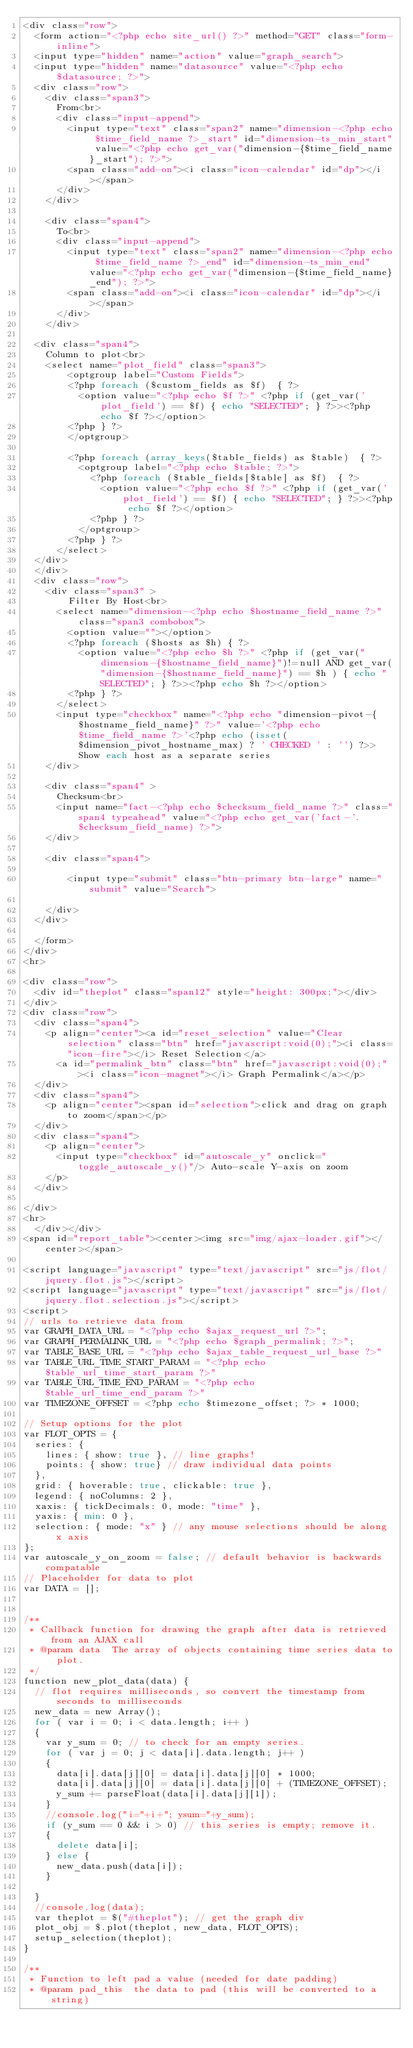<code> <loc_0><loc_0><loc_500><loc_500><_PHP_><div class="row">
	<form action="<?php echo site_url() ?>" method="GET" class="form-inline">
	<input type="hidden" name="action" value="graph_search">
	<input type="hidden" name="datasource" value="<?php echo $datasource; ?>">
	<div class="row">
		<div class="span3">
			From<br>
			<div class="input-append">
				<input type="text" class="span2" name="dimension-<?php echo $time_field_name ?>_start" id="dimension-ts_min_start" value="<?php echo get_var("dimension-{$time_field_name}_start"); ?>">
				<span class="add-on"><i class="icon-calendar" id="dp"></i></span>
			</div>
		</div>

		<div class="span4">
			To<br>
			<div class="input-append">
				<input type="text" class="span2" name="dimension-<?php echo $time_field_name ?>_end" id="dimension-ts_min_end" value="<?php echo get_var("dimension-{$time_field_name}_end"); ?>">
				<span class="add-on"><i class="icon-calendar" id="dp"></i></span>
			</div>
		</div>

	<div class="span4">
		Column to plot<br>
		<select name="plot_field" class="span3">
				<optgroup label="Custom Fields">
				<?php foreach ($custom_fields as $f)  { ?>
					<option value="<?php echo $f ?>" <?php if (get_var('plot_field') == $f) { echo "SELECTED"; } ?>><?php echo $f ?></option>
				<?php } ?>
				</optgroup>

				<?php foreach (array_keys($table_fields) as $table)  { ?>
					<optgroup label="<?php echo $table; ?>">
						<?php foreach ($table_fields[$table] as $f)  { ?>
							<option value="<?php echo $f ?>" <?php if (get_var('plot_field') == $f) { echo "SELECTED"; } ?>><?php echo $f ?></option>
						<?php } ?>
					</optgroup>
				<?php } ?>
			</select>
	</div>
	</div>
	<div class="row">
		<div class="span3" >
				Filter By Host<br>
			<select name="dimension-<?php echo $hostname_field_name ?>" class="span3 combobox">
				<option value=""></option>
				<?php foreach ($hosts as $h) { ?>
					<option value="<?php echo $h ?>" <?php if (get_var("dimension-{$hostname_field_name}")!=null AND get_var("dimension-{$hostname_field_name}") == $h ) { echo "SELECTED"; } ?>><?php echo $h ?></option>
				<?php } ?>
			</select>
			<input type="checkbox" name="<?php echo "dimension-pivot-{$hostname_field_name}" ?>" value='<?php echo $time_field_name ?>'<?php echo (isset($dimension_pivot_hostname_max) ? ' CHECKED ' : '') ?>> Show each host as a separate series
		</div>

		<div class="span4" >
			Checksum<br>
			<input name="fact-<?php echo $checksum_field_name ?>" class="span4 typeahead" value="<?php echo get_var('fact-'.$checksum_field_name) ?>">
		</div>

		<div class="span4">

				<input type="submit" class="btn-primary btn-large" name="submit" value="Search">

		</div>
	</div>

	</form>
</div>
<hr>

<div class="row">
	<div id="theplot" class="span12" style="height: 300px;"></div>
</div>
<div class="row">
	<div class="span4">
		<p align="center"><a id="reset_selection" value="Clear selection" class="btn" href="javascript:void(0);"><i class="icon-fire"></i> Reset Selection</a>
			<a id="permalink_btn" class="btn" href="javascript:void(0);"><i class="icon-magnet"></i> Graph Permalink</a></p>
	</div>
	<div class="span4">
		<p align="center"><span id="selection">click and drag on graph to zoom</span></p>
	</div>
	<div class="span4">
		<p align="center">
			<input type="checkbox" id="autoscale_y" onclick="toggle_autoscale_y()"/> Auto-scale Y-axis on zoom
		</p>
	</div>

</div>
<hr>
	</div></div>
<span id="report_table"><center><img src="img/ajax-loader.gif"></center></span>

<script language="javascript" type="text/javascript" src="js/flot/jquery.flot.js"></script>
<script language="javascript" type="text/javascript" src="js/flot/jquery.flot.selection.js"></script>
<script>
// urls to retrieve data from
var GRAPH_DATA_URL = "<?php echo $ajax_request_url ?>";
var GRAPH_PERMALINK_URL = "<?php echo $graph_permalink; ?>";
var TABLE_BASE_URL = "<?php echo $ajax_table_request_url_base ?>"
var TABLE_URL_TIME_START_PARAM = "<?php echo $table_url_time_start_param ?>"
var TABLE_URL_TIME_END_PARAM = "<?php echo $table_url_time_end_param ?>"
var TIMEZONE_OFFSET = <?php echo $timezone_offset; ?> * 1000;

// Setup options for the plot
var FLOT_OPTS = {
	series: {
		lines: { show: true }, // line graphs!
		points: { show: true} // draw individual data points
	},
	grid: { hoverable: true, clickable: true },
	legend: { noColumns: 2 },
	xaxis: { tickDecimals: 0, mode: "time" },
	yaxis: { min: 0 },
	selection: { mode: "x" } // any mouse selections should be along x axis
};
var autoscale_y_on_zoom = false; // default behavior is backwards compatable
// Placeholder for data to plot
var DATA = [];


/**
 * Callback function for drawing the graph after data is retrieved from an AJAX call
 * @param data 	The array of objects containing time series data to plot.
 */
function new_plot_data(data) {
	// flot requires milliseconds, so convert the timestamp from seconds to milliseconds
	new_data = new Array();
	for ( var i = 0; i < data.length; i++ )
	{
		var y_sum = 0; // to check for an empty series.
		for ( var j = 0; j < data[i].data.length; j++ )
		{
			data[i].data[j][0] = data[i].data[j][0] * 1000;
			data[i].data[j][0] = data[i].data[j][0] + (TIMEZONE_OFFSET);
			y_sum += parseFloat(data[i].data[j][1]);
		}
		//console.log("i="+i+"; ysum="+y_sum);
		if (y_sum == 0 && i > 0) // this series is empty; remove it.
		{
			delete data[i];
		} else {
			new_data.push(data[i]);
		}

	}
	//console.log(data);
	var theplot = $("#theplot"); // get the graph div
	plot_obj = $.plot(theplot, new_data, FLOT_OPTS);
	setup_selection(theplot);
}

/**
 * Function to left pad a value (needed for date padding)
 * @param pad_this 	the data to pad (this will be converted to a string)</code> 